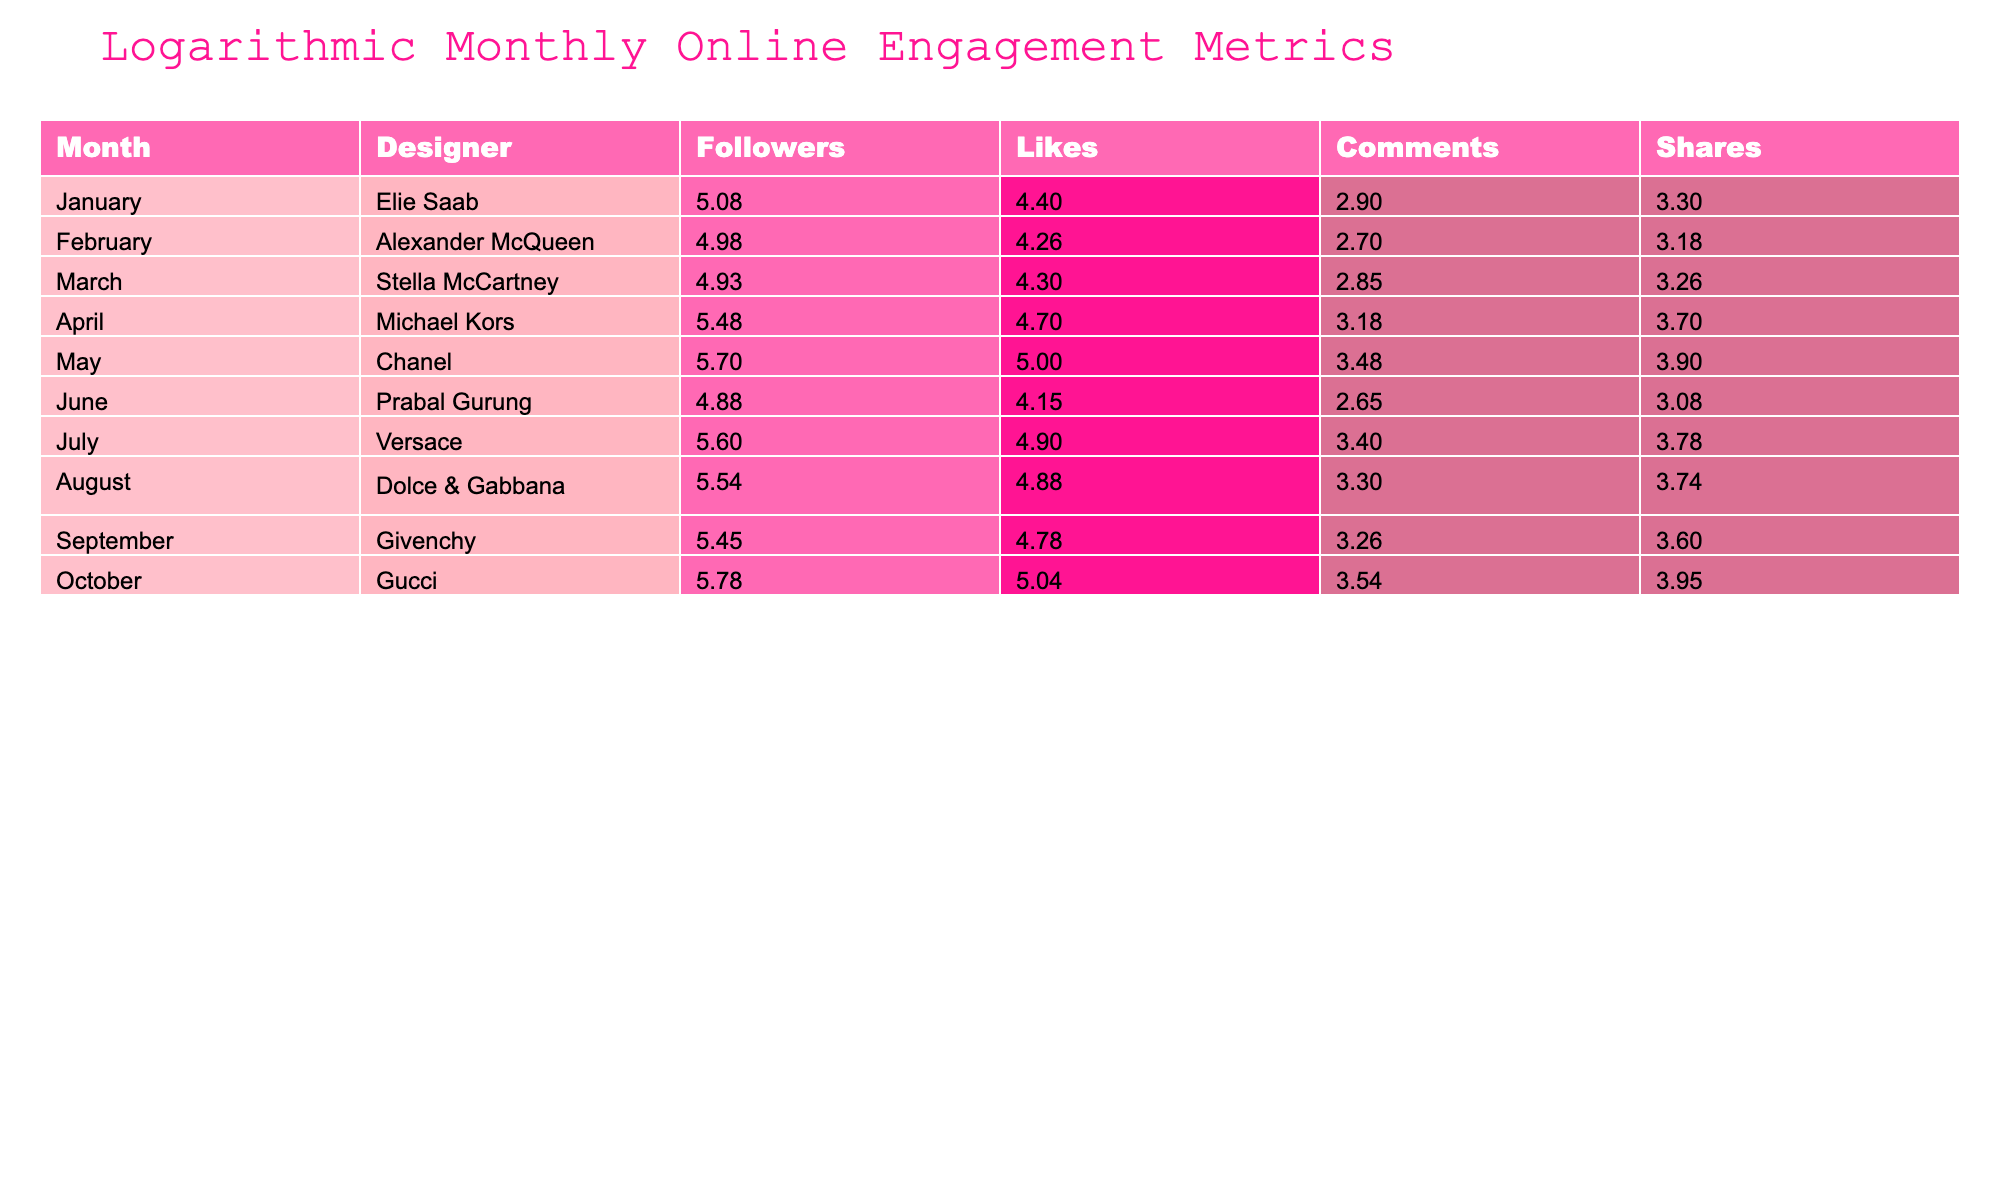What is the logarithmic value of likes for Chanel? The logarithmic value for likes is calculated by taking the base-10 logarithm of the number of likes for Chanel, which is 100000. So, log10(100000) = 5.0
Answer: 5.0 Which designer received the most comments in a month? Looking at the Comments column, the designer with the highest number of comments is Michael Kors with 1500.
Answer: Michael Kors What is the total number of shares for all designers combined in October? To find the total shares, we look at the Shares column for October. The value is 9000 for Gucci.
Answer: 9000 Is the number of followers for Versace greater than the number of followers for Prabal Gurung? Versace has 400000 followers, while Prabal Gurung has 75000 followers. Since 400000 is greater than 75000, the statement is true.
Answer: Yes What is the average logarithmic value of followers across all designers? First, we sum the logarithmic values of the Followers column. The values are log10(120000), log10(95000), log10(85000), log10(300000), log10(500000), log10(75000), log10(400000), log10(350000), log10(280000), log10(600000). The sum of these values is approximately 10.5, and there are 10 designers. So, the average is 10.5/10 ≈ 1.05.
Answer: 1.05 How many designers have more than 300000 followers? The designers with more than 300000 followers are Michael Kors, Chanel, and Gucci. Counting them gives a total of 3 designers.
Answer: 3 